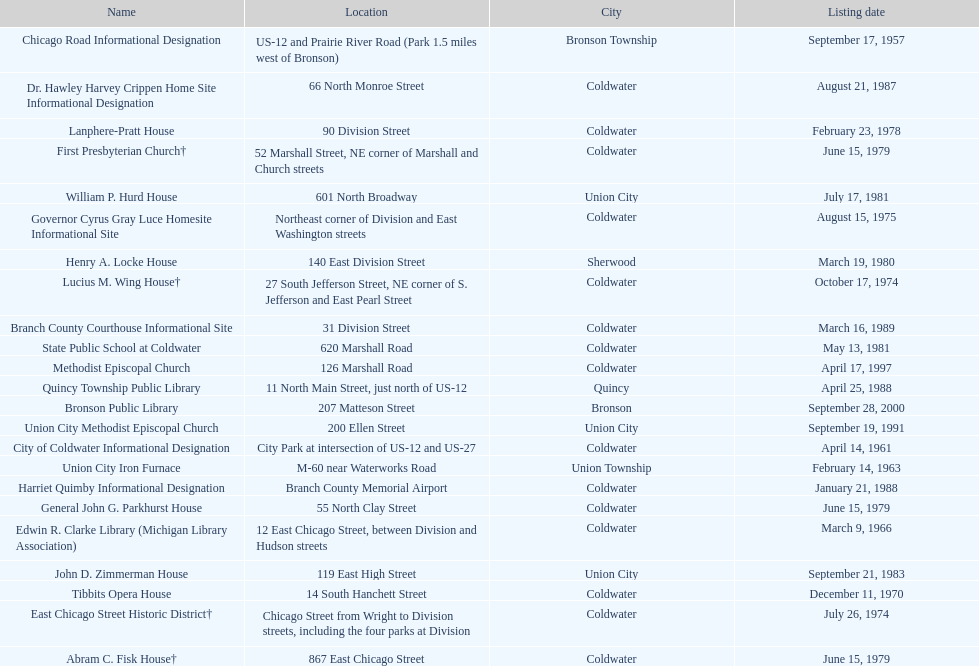How many historic sites were listed before 1965? 3. 